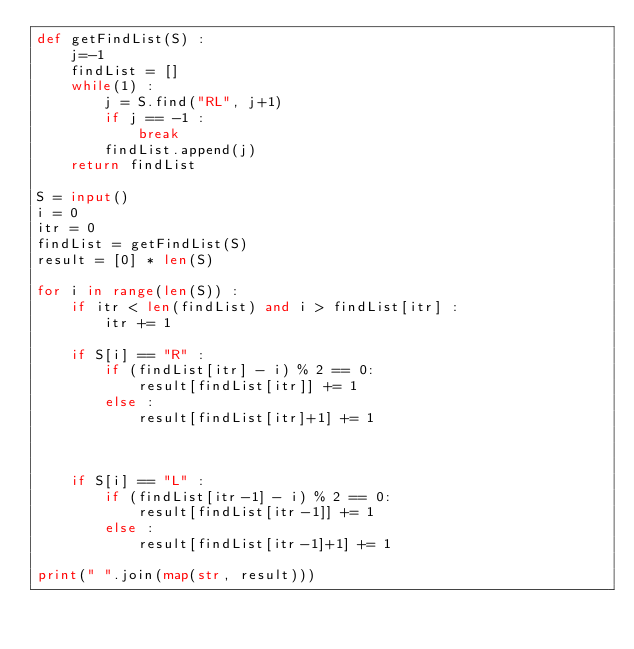<code> <loc_0><loc_0><loc_500><loc_500><_Python_>def getFindList(S) :
    j=-1
    findList = []
    while(1) :
        j = S.find("RL", j+1)
        if j == -1 :
            break
        findList.append(j)
    return findList

S = input()
i = 0
itr = 0
findList = getFindList(S)
result = [0] * len(S)

for i in range(len(S)) :
    if itr < len(findList) and i > findList[itr] :
        itr += 1
        
    if S[i] == "R" :
        if (findList[itr] - i) % 2 == 0:
            result[findList[itr]] += 1
        else :
            result[findList[itr]+1] += 1
        
        
        
    if S[i] == "L" : 
        if (findList[itr-1] - i) % 2 == 0:
            result[findList[itr-1]] += 1
        else :
            result[findList[itr-1]+1] += 1
        
print(" ".join(map(str, result)))</code> 